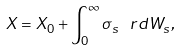<formula> <loc_0><loc_0><loc_500><loc_500>X = X _ { 0 } + \int _ { 0 } ^ { \infty } \sigma _ { s } \, \ r d W _ { s } ,</formula> 